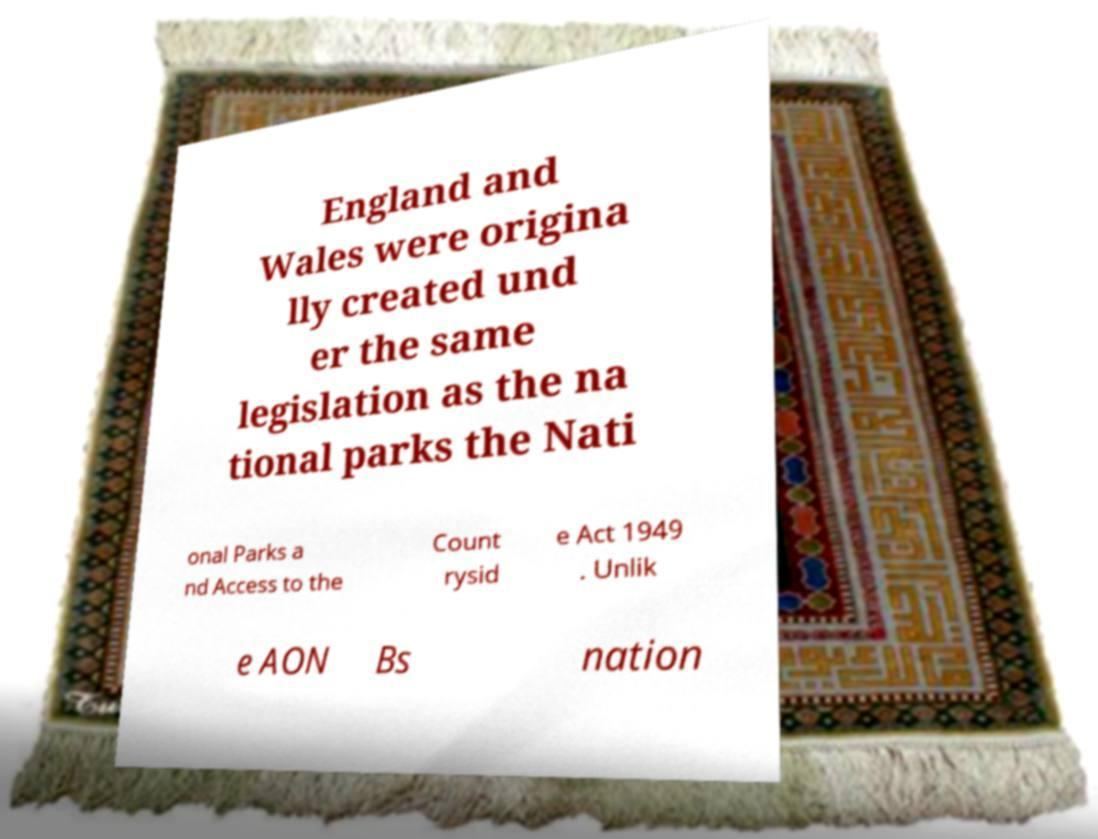Please read and relay the text visible in this image. What does it say? England and Wales were origina lly created und er the same legislation as the na tional parks the Nati onal Parks a nd Access to the Count rysid e Act 1949 . Unlik e AON Bs nation 